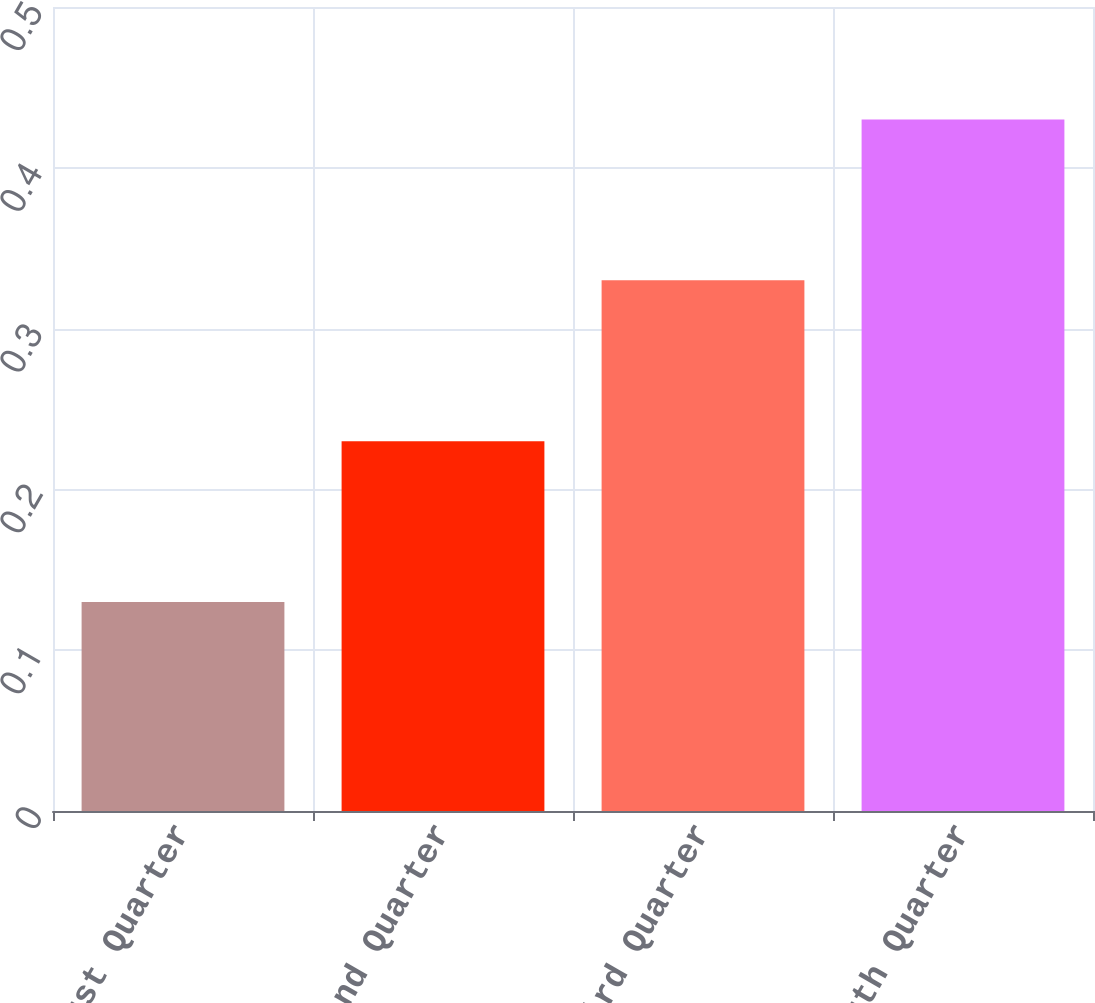Convert chart. <chart><loc_0><loc_0><loc_500><loc_500><bar_chart><fcel>First Quarter<fcel>Second Quarter<fcel>Third Quarter<fcel>Fourth Quarter<nl><fcel>0.13<fcel>0.23<fcel>0.33<fcel>0.43<nl></chart> 